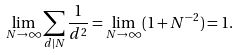<formula> <loc_0><loc_0><loc_500><loc_500>\lim _ { N \rightarrow \infty } \sum _ { d | N } \frac { 1 } { d ^ { 2 } } = \lim _ { N \rightarrow \infty } ( 1 + N ^ { - 2 } ) = 1 .</formula> 